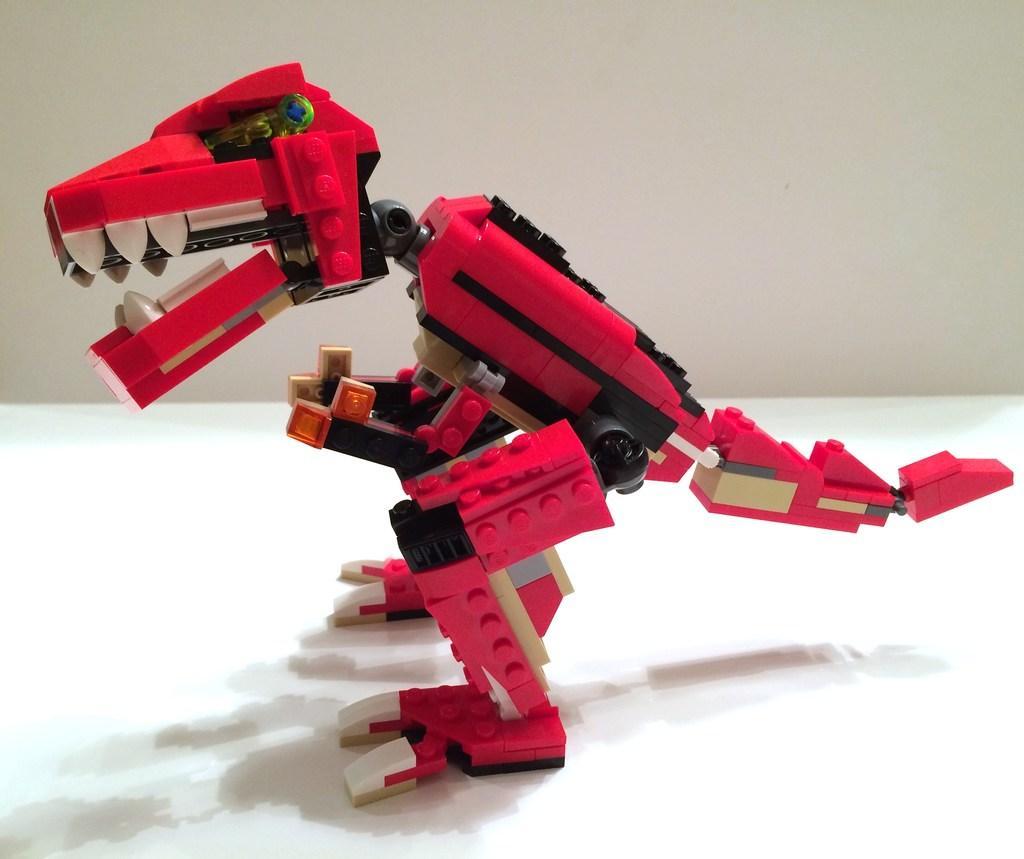Can you describe this image briefly? In this picture we can see a red color toy in the front, in the background there is a wall. 